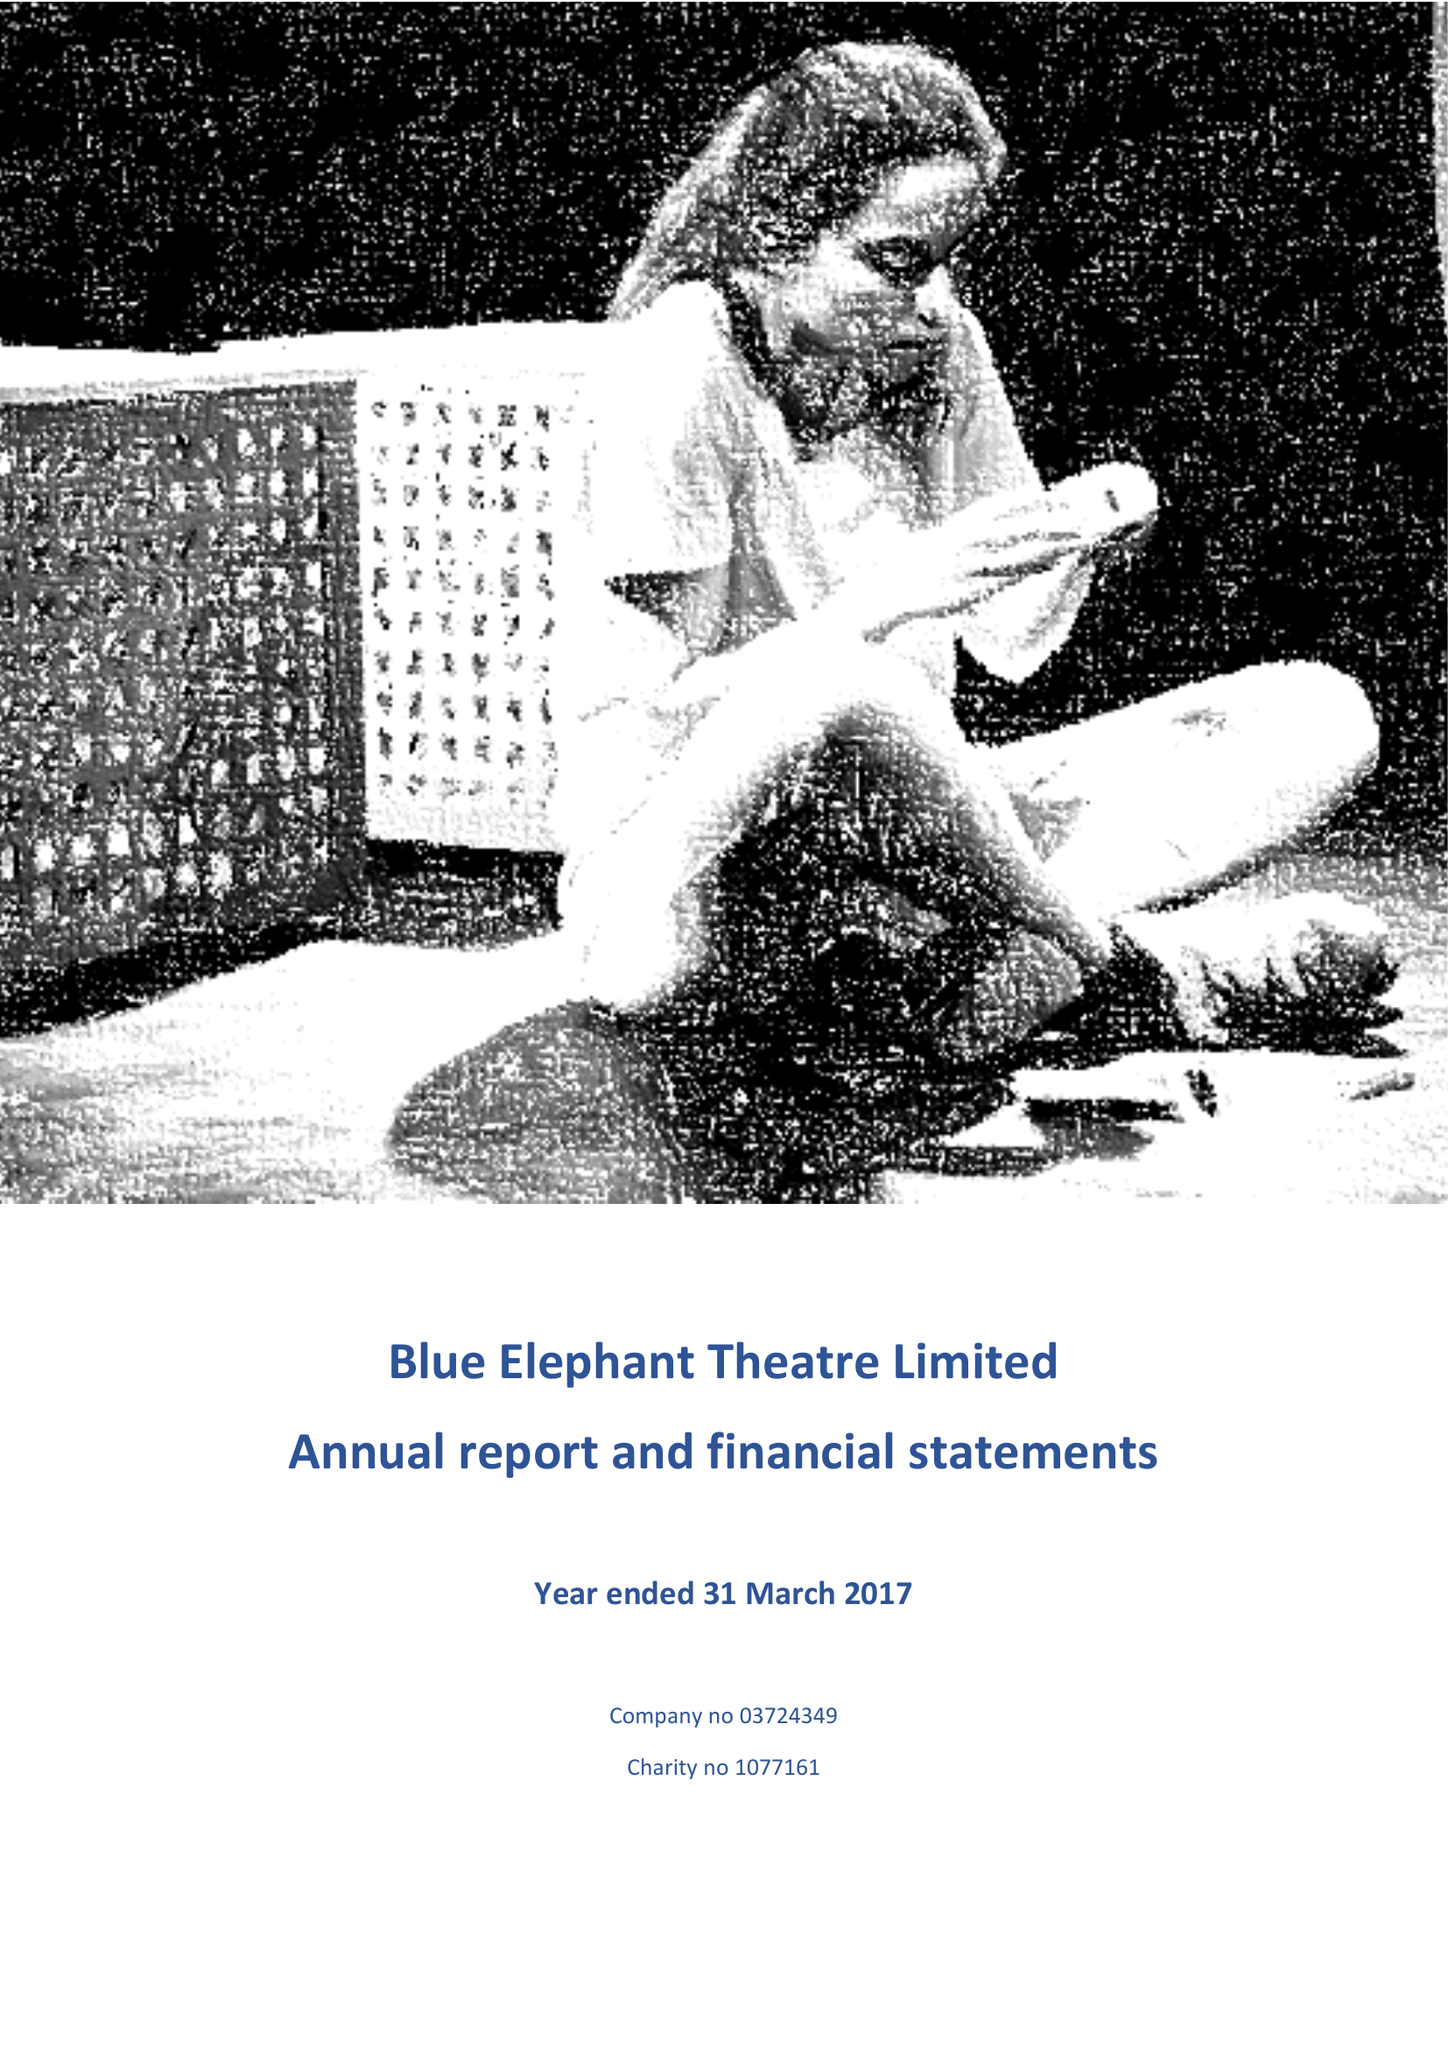What is the value for the address__postcode?
Answer the question using a single word or phrase. SE5 0XT 